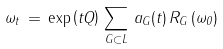Convert formula to latex. <formula><loc_0><loc_0><loc_500><loc_500>\omega _ { t } \, = \, \exp \left ( t Q \right ) \, \sum _ { G \subset L } \, a _ { G } ( t ) \, R _ { G } \, ( \omega _ { 0 } )</formula> 